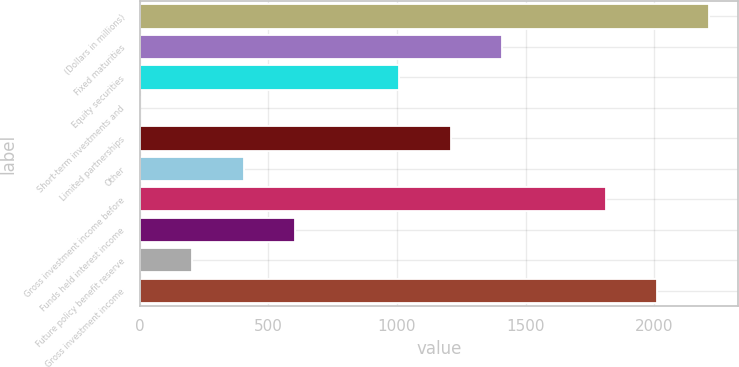Convert chart to OTSL. <chart><loc_0><loc_0><loc_500><loc_500><bar_chart><fcel>(Dollars in millions)<fcel>Fixed maturities<fcel>Equity securities<fcel>Short-term investments and<fcel>Limited partnerships<fcel>Other<fcel>Gross investment income before<fcel>Funds held interest income<fcel>Future policy benefit reserve<fcel>Gross investment income<nl><fcel>2214.17<fcel>1409.49<fcel>1007.15<fcel>1.3<fcel>1208.32<fcel>403.64<fcel>1811.83<fcel>604.81<fcel>202.47<fcel>2013<nl></chart> 